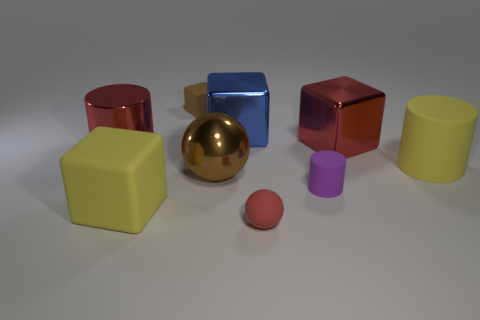Add 1 yellow rubber cylinders. How many objects exist? 10 Subtract all blocks. How many objects are left? 5 Subtract 0 cyan cubes. How many objects are left? 9 Subtract all red metal things. Subtract all brown matte things. How many objects are left? 6 Add 4 tiny matte spheres. How many tiny matte spheres are left? 5 Add 2 metallic objects. How many metallic objects exist? 6 